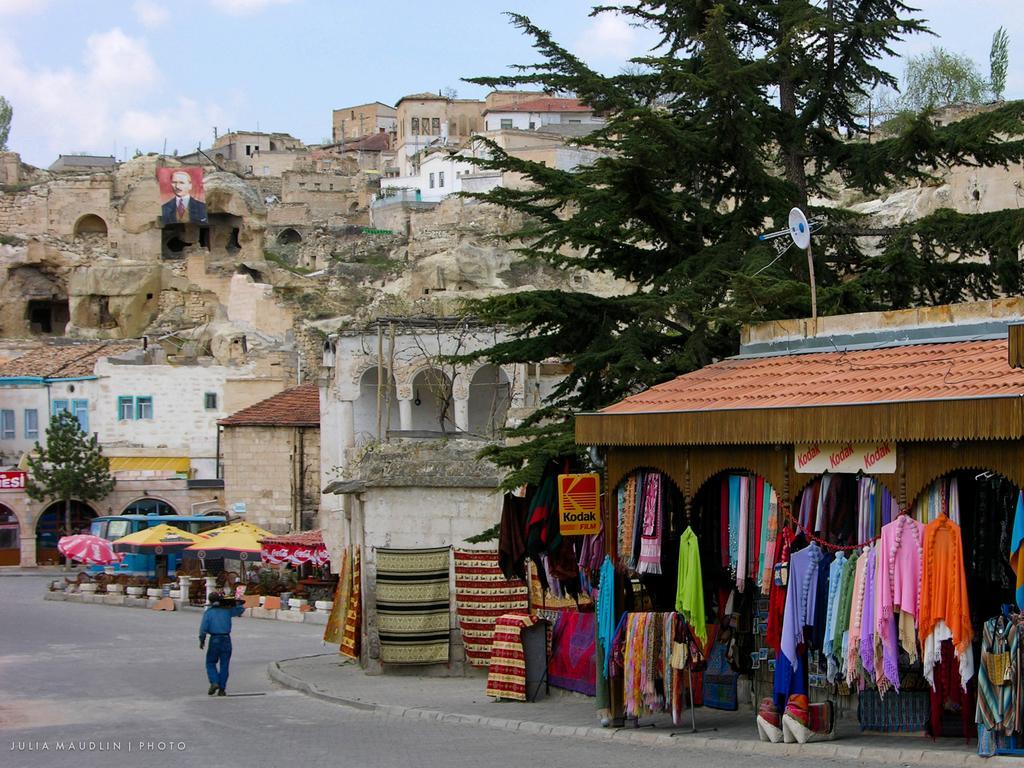How would you summarize this image in a sentence or two? In the picture I can see the cloth store house on the right side. There are trees on the top right side. In the background, I can see the houses. There are clouds in the sky. I can see the banner of a man on the left side. I can see a man walking on the road and he is on the bottom left side. I can see the tents on the side of the road and I can see a vehicle on the road. 